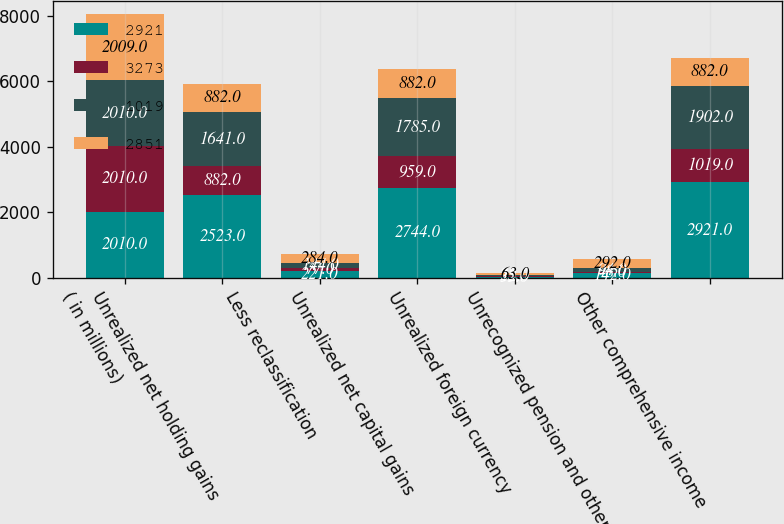Convert chart to OTSL. <chart><loc_0><loc_0><loc_500><loc_500><stacked_bar_chart><ecel><fcel>( in millions)<fcel>Unrealized net holding gains<fcel>Less reclassification<fcel>Unrealized net capital gains<fcel>Unrealized foreign currency<fcel>Unrecognized pension and other<fcel>Other comprehensive income<nl><fcel>2921<fcel>2010<fcel>2523<fcel>221<fcel>2744<fcel>35<fcel>142<fcel>2921<nl><fcel>3273<fcel>2010<fcel>882<fcel>77<fcel>959<fcel>12<fcel>48<fcel>1019<nl><fcel>1019<fcel>2010<fcel>1641<fcel>144<fcel>1785<fcel>23<fcel>94<fcel>1902<nl><fcel>2851<fcel>2009<fcel>882<fcel>284<fcel>882<fcel>63<fcel>292<fcel>882<nl></chart> 